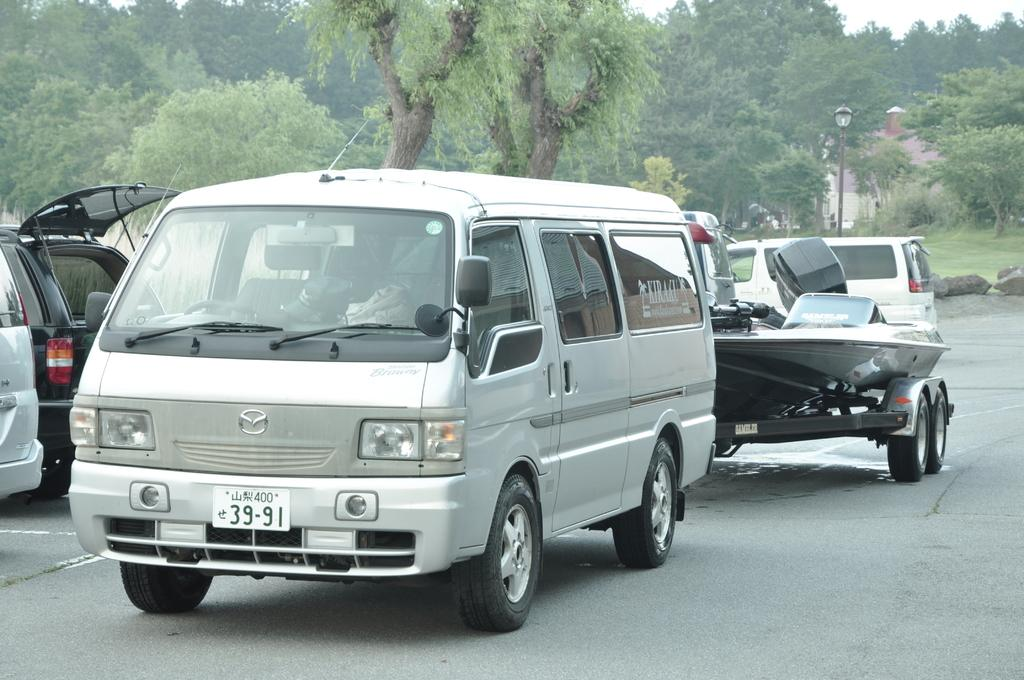<image>
Share a concise interpretation of the image provided. A van with license plate 39-91 and Kiraku on the back side window, pulls a boat through a parking lot. 